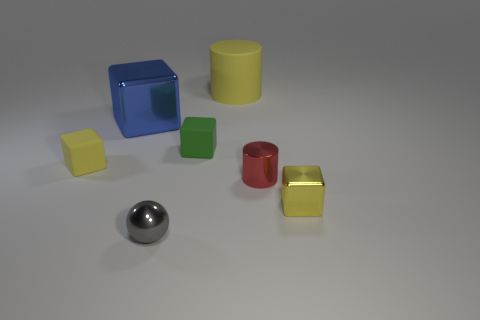What number of gray matte things are there?
Make the answer very short. 0. Is the color of the matte cylinder the same as the cube in front of the tiny yellow rubber object?
Offer a terse response. Yes. Is the number of blue metallic blocks greater than the number of objects?
Offer a very short reply. No. Is there any other thing that is the same color as the big rubber object?
Make the answer very short. Yes. How many other things are the same size as the matte cylinder?
Make the answer very short. 1. What is the object that is in front of the shiny block to the right of the small object that is in front of the small yellow metallic block made of?
Ensure brevity in your answer.  Metal. Is the material of the large yellow object the same as the yellow block that is on the left side of the small yellow shiny thing?
Keep it short and to the point. Yes. Are there fewer blue metal objects that are in front of the tiny red cylinder than balls behind the tiny metallic block?
Keep it short and to the point. No. What number of green cubes are the same material as the big blue block?
Ensure brevity in your answer.  0. Is there a big shiny object that is left of the yellow object in front of the yellow thing to the left of the gray sphere?
Your answer should be compact. Yes. 